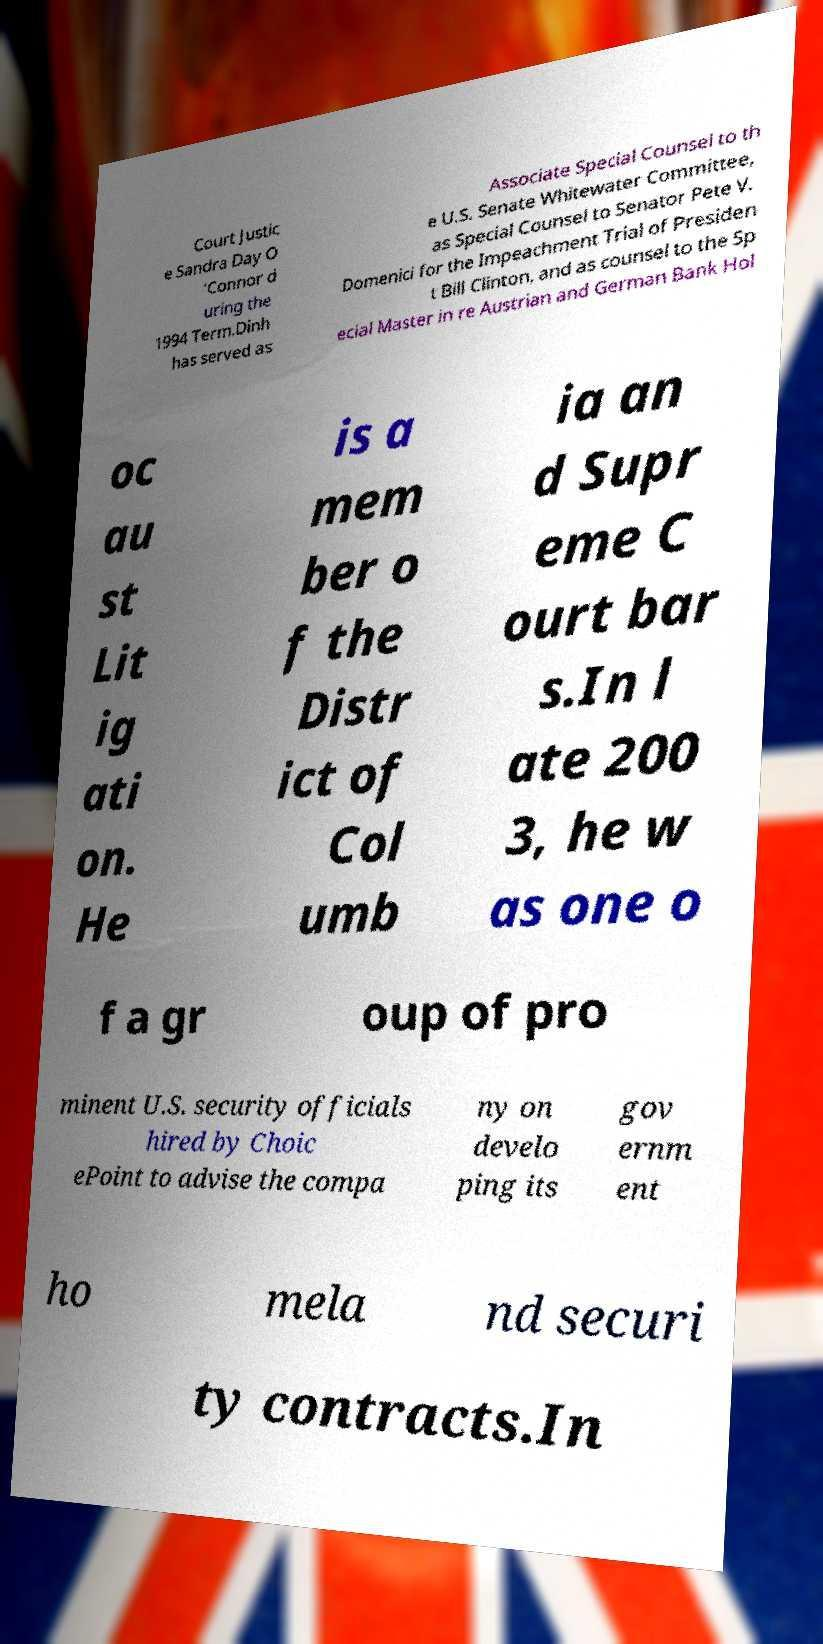Can you accurately transcribe the text from the provided image for me? Court Justic e Sandra Day O 'Connor d uring the 1994 Term.Dinh has served as Associate Special Counsel to th e U.S. Senate Whitewater Committee, as Special Counsel to Senator Pete V. Domenici for the Impeachment Trial of Presiden t Bill Clinton, and as counsel to the Sp ecial Master in re Austrian and German Bank Hol oc au st Lit ig ati on. He is a mem ber o f the Distr ict of Col umb ia an d Supr eme C ourt bar s.In l ate 200 3, he w as one o f a gr oup of pro minent U.S. security officials hired by Choic ePoint to advise the compa ny on develo ping its gov ernm ent ho mela nd securi ty contracts.In 